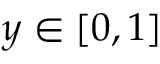Convert formula to latex. <formula><loc_0><loc_0><loc_500><loc_500>y \in [ 0 , 1 ]</formula> 